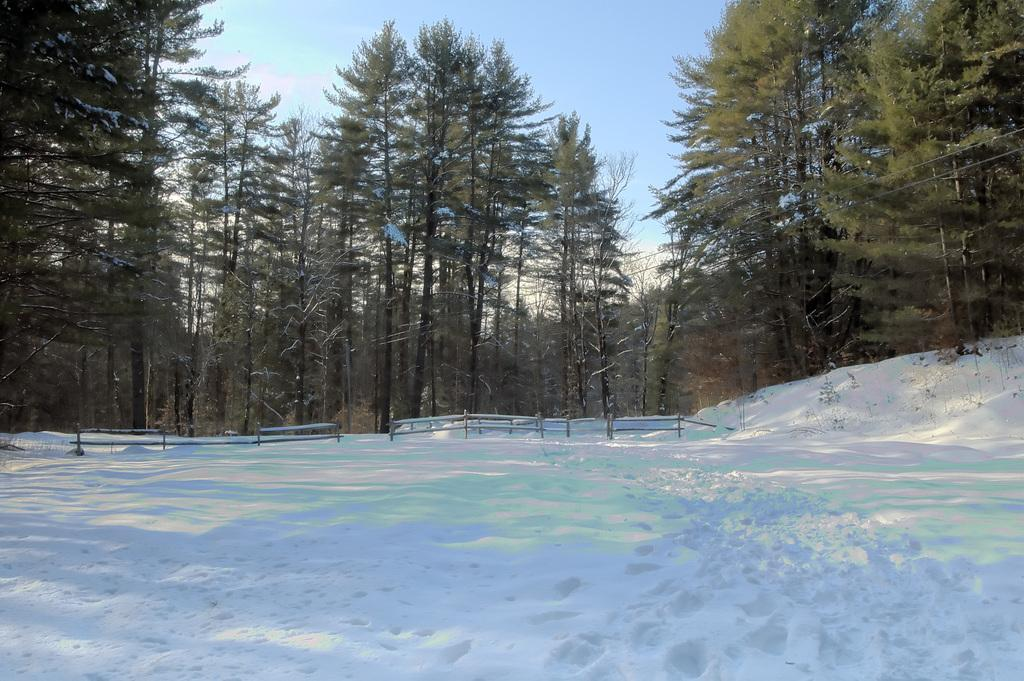What is the condition of the ground in the image? The ground in the image is covered in snow. What can be seen in the background of the image? There are trees in the background of the image. What is visible at the top of the image? The sky is visible at the top of the image. How many vases are present in the image? There are no vases present in the image. What type of army can be seen marching through the snow in the image? There is no army present in the image; it only features snow-covered ground, trees, and the sky. 